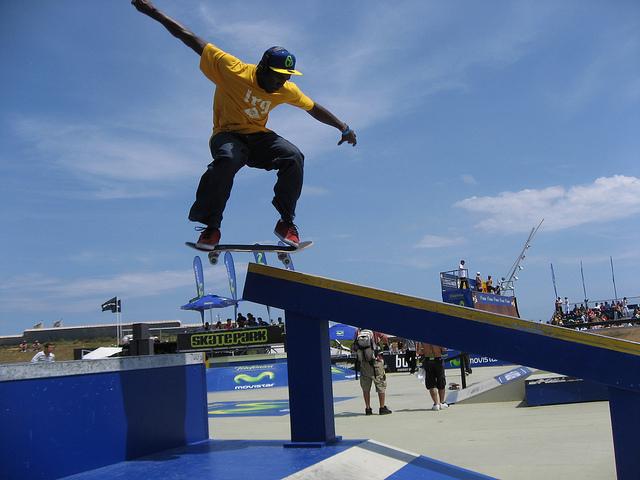Is anyone wearing a backpack?
Answer briefly. Yes. Is he right handed?
Write a very short answer. Yes. Is this a skate park?
Give a very brief answer. Yes. 